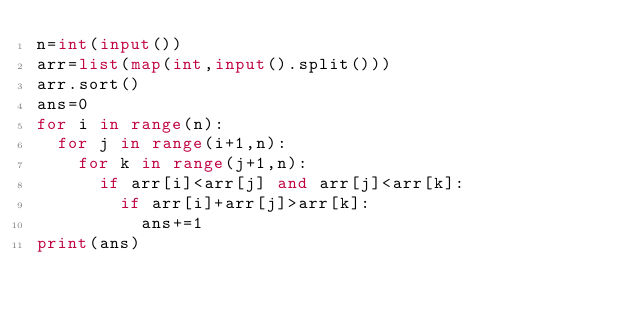<code> <loc_0><loc_0><loc_500><loc_500><_Python_>n=int(input())
arr=list(map(int,input().split()))
arr.sort()
ans=0
for i in range(n):
  for j in range(i+1,n):
    for k in range(j+1,n):
      if arr[i]<arr[j] and arr[j]<arr[k]:
        if arr[i]+arr[j]>arr[k]:
          ans+=1
print(ans)
</code> 